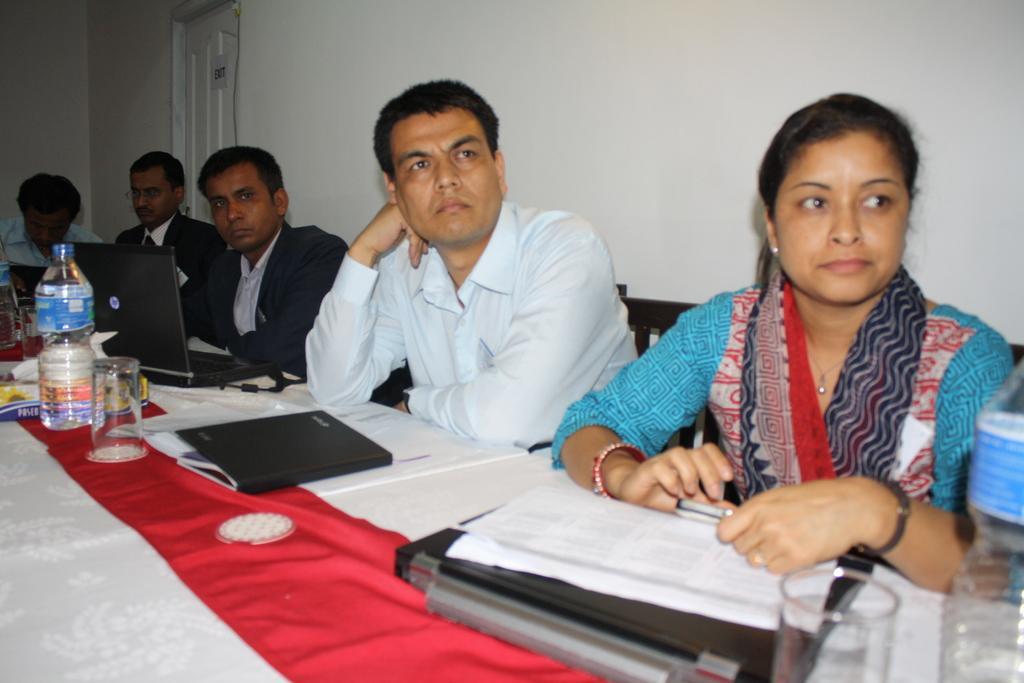How would you summarize this image in a sentence or two? In this image, we can see people sitting and on the table, there are books, bottles, glasses and we can see laptops and some other objects and a cloth are placed on the table. In the background, there is a door and there is a wall. 